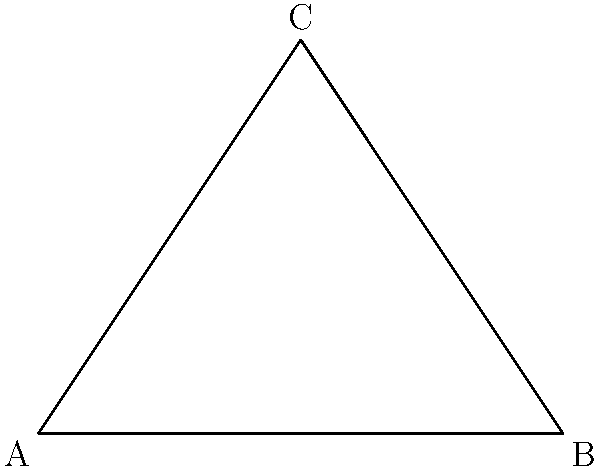In a performance art piece, a dancer is imitating a frog's leap. At the apex of the jump, the dancer's legs form a triangle as shown in the diagram. If the angle between the ground and one leg is 60°, what is the angle $x$ between the two legs? Let's approach this step-by-step:

1) First, we need to recognize that the triangle formed by the dancer's legs is a right-angled triangle. This is because one side represents the ground (horizontal), and one leg is perpendicular to the ground at the peak of the jump.

2) In a right-angled triangle, the sum of all angles is 180°, and one of these angles is always 90°.

3) We are given that one of the other angles is 60°.

4) Let's call the unknown angle $x°$.

5) We can set up an equation based on the fact that all angles in a triangle sum to 180°:

   $90° + 60° + x° = 180°$

6) Simplifying:
   
   $150° + x° = 180°$

7) Subtracting 150° from both sides:

   $x° = 180° - 150° = 30°$

Therefore, the angle between the two legs is 30°.
Answer: $30°$ 